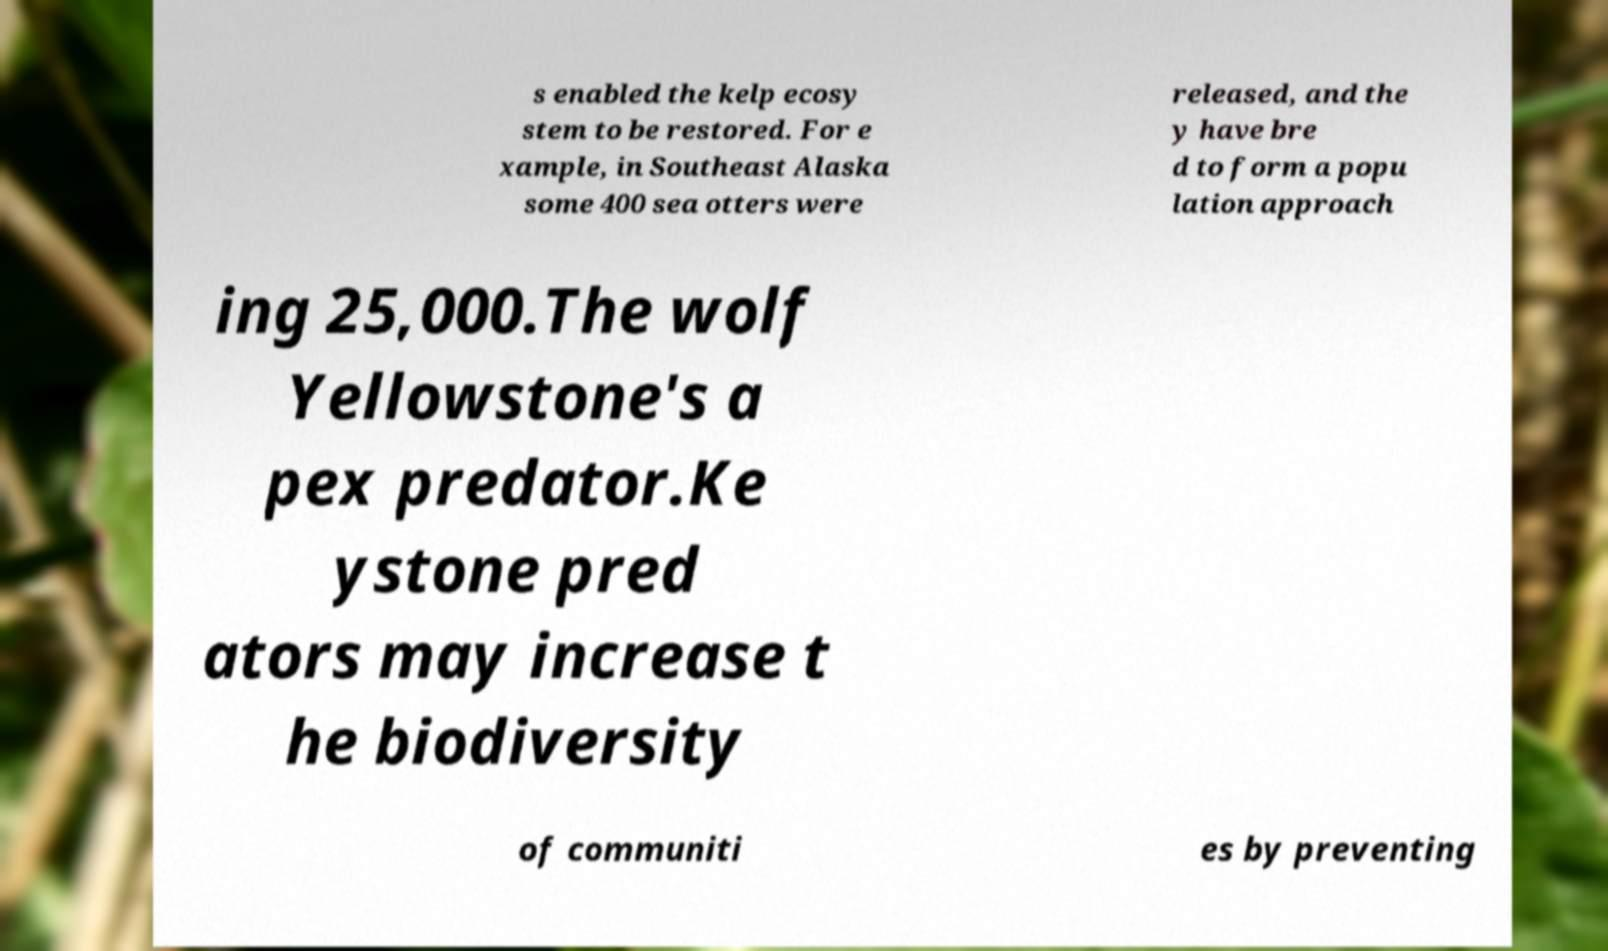What messages or text are displayed in this image? I need them in a readable, typed format. s enabled the kelp ecosy stem to be restored. For e xample, in Southeast Alaska some 400 sea otters were released, and the y have bre d to form a popu lation approach ing 25,000.The wolf Yellowstone's a pex predator.Ke ystone pred ators may increase t he biodiversity of communiti es by preventing 